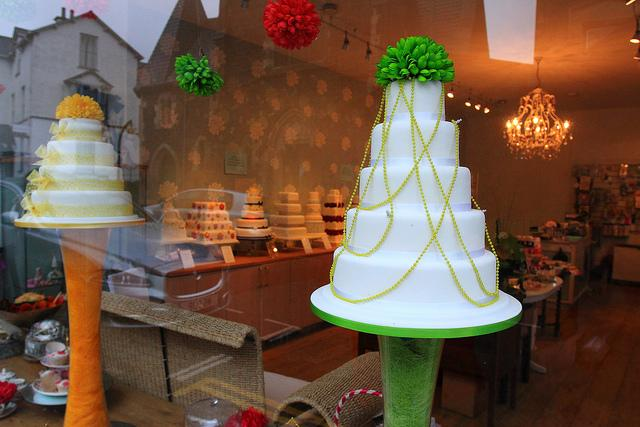What is inside of the large cake with green top and bottom?

Choices:
A) caramel
B) nothing
C) chocolate
D) coconut nothing 